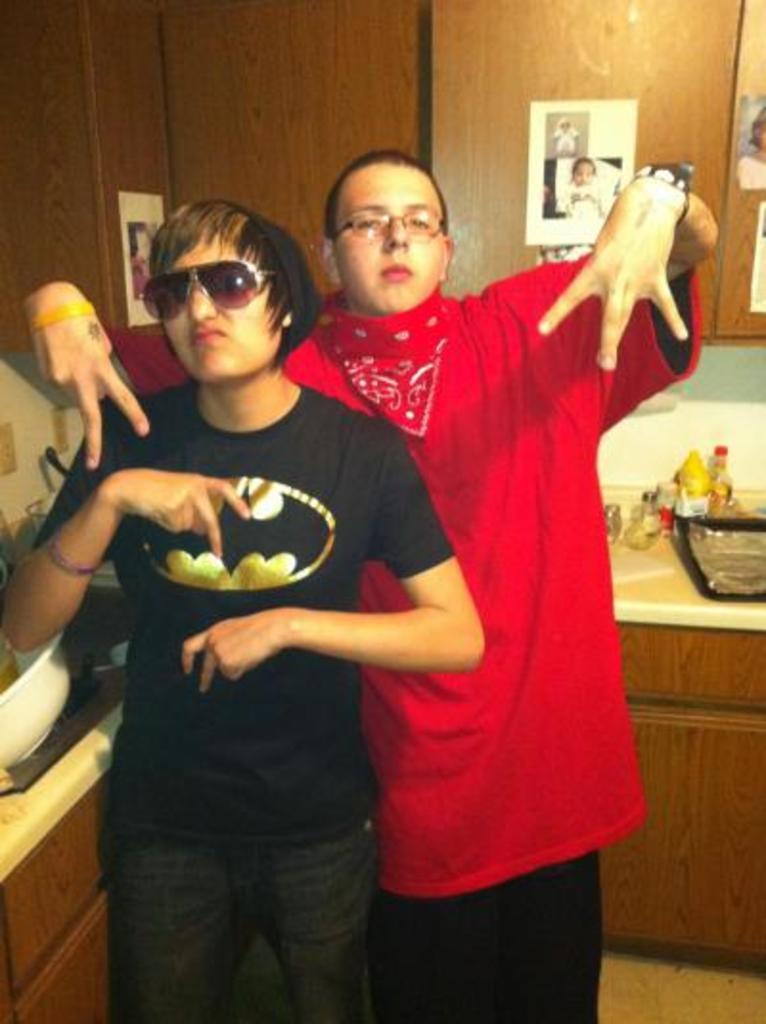Please provide a concise description of this image. In this image we can see two persons. Behind the persons we can see cupboards and few objects on the shelf. There are few photos on the cupboards. 